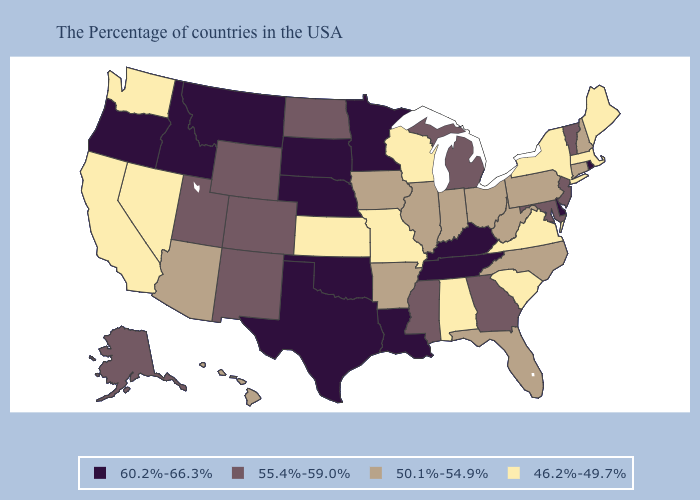Does the first symbol in the legend represent the smallest category?
Short answer required. No. Name the states that have a value in the range 46.2%-49.7%?
Write a very short answer. Maine, Massachusetts, New York, Virginia, South Carolina, Alabama, Wisconsin, Missouri, Kansas, Nevada, California, Washington. Which states have the highest value in the USA?
Be succinct. Rhode Island, Delaware, Kentucky, Tennessee, Louisiana, Minnesota, Nebraska, Oklahoma, Texas, South Dakota, Montana, Idaho, Oregon. Which states have the highest value in the USA?
Quick response, please. Rhode Island, Delaware, Kentucky, Tennessee, Louisiana, Minnesota, Nebraska, Oklahoma, Texas, South Dakota, Montana, Idaho, Oregon. What is the lowest value in the USA?
Answer briefly. 46.2%-49.7%. What is the highest value in the West ?
Concise answer only. 60.2%-66.3%. Which states have the lowest value in the West?
Quick response, please. Nevada, California, Washington. What is the value of Illinois?
Short answer required. 50.1%-54.9%. Among the states that border Wyoming , does Idaho have the highest value?
Keep it brief. Yes. What is the highest value in states that border Delaware?
Keep it brief. 55.4%-59.0%. What is the value of Hawaii?
Answer briefly. 50.1%-54.9%. What is the highest value in the USA?
Keep it brief. 60.2%-66.3%. What is the lowest value in the USA?
Quick response, please. 46.2%-49.7%. What is the value of Arizona?
Concise answer only. 50.1%-54.9%. Does Kansas have the highest value in the USA?
Short answer required. No. 